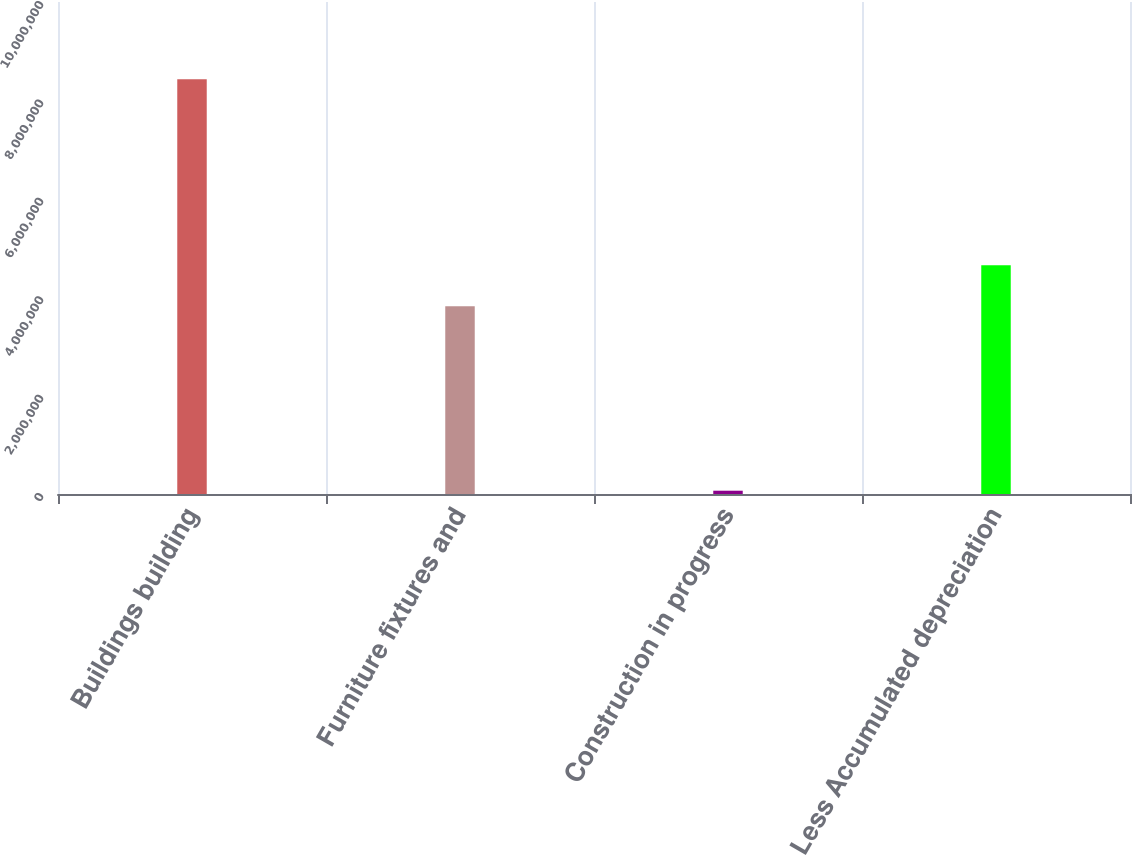Convert chart. <chart><loc_0><loc_0><loc_500><loc_500><bar_chart><fcel>Buildings building<fcel>Furniture fixtures and<fcel>Construction in progress<fcel>Less Accumulated depreciation<nl><fcel>8.42877e+06<fcel>3.8146e+06<fcel>66902<fcel>4.65078e+06<nl></chart> 